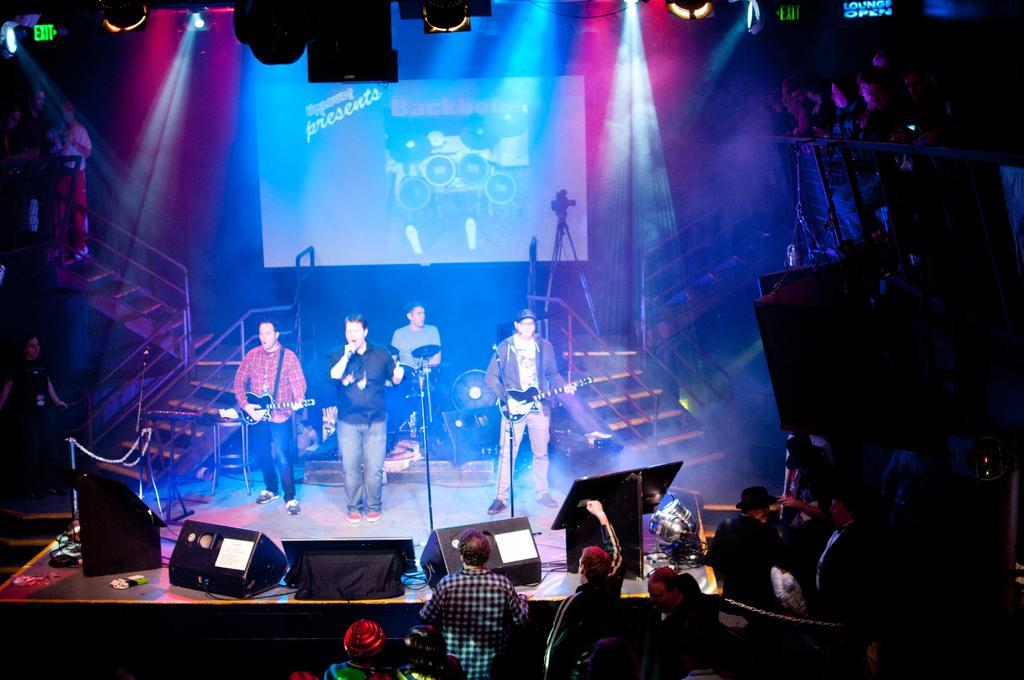In one or two sentences, can you explain what this image depicts? In this image we can see some people and among them few people playing musical instruments on the stage. There are some objects like stage lighting, speakers and some other things on the stage and we can see the stairs and there is a screen with some text and the picture in the background. 